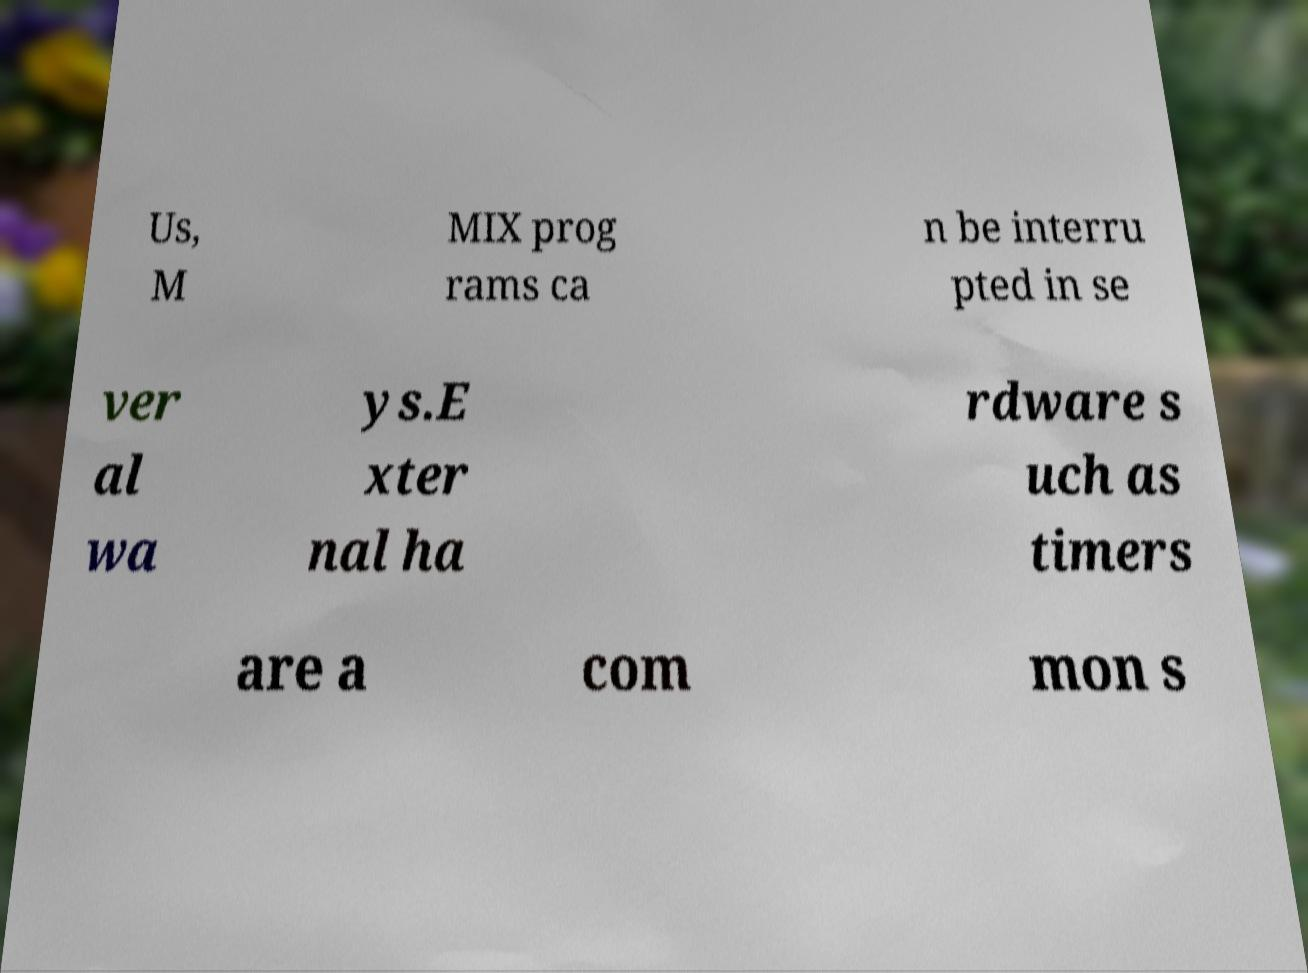Can you accurately transcribe the text from the provided image for me? Us, M MIX prog rams ca n be interru pted in se ver al wa ys.E xter nal ha rdware s uch as timers are a com mon s 